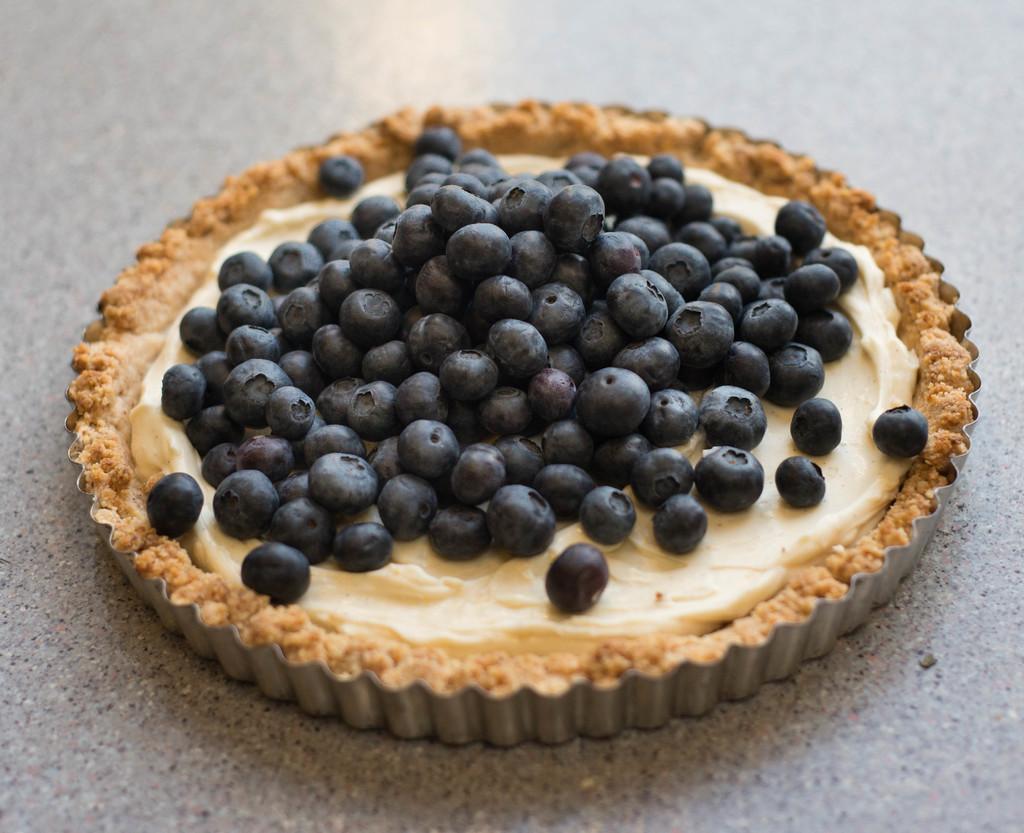Describe this image in one or two sentences. This image consists of a pancake on which there are black grapes is kept on the floor. 